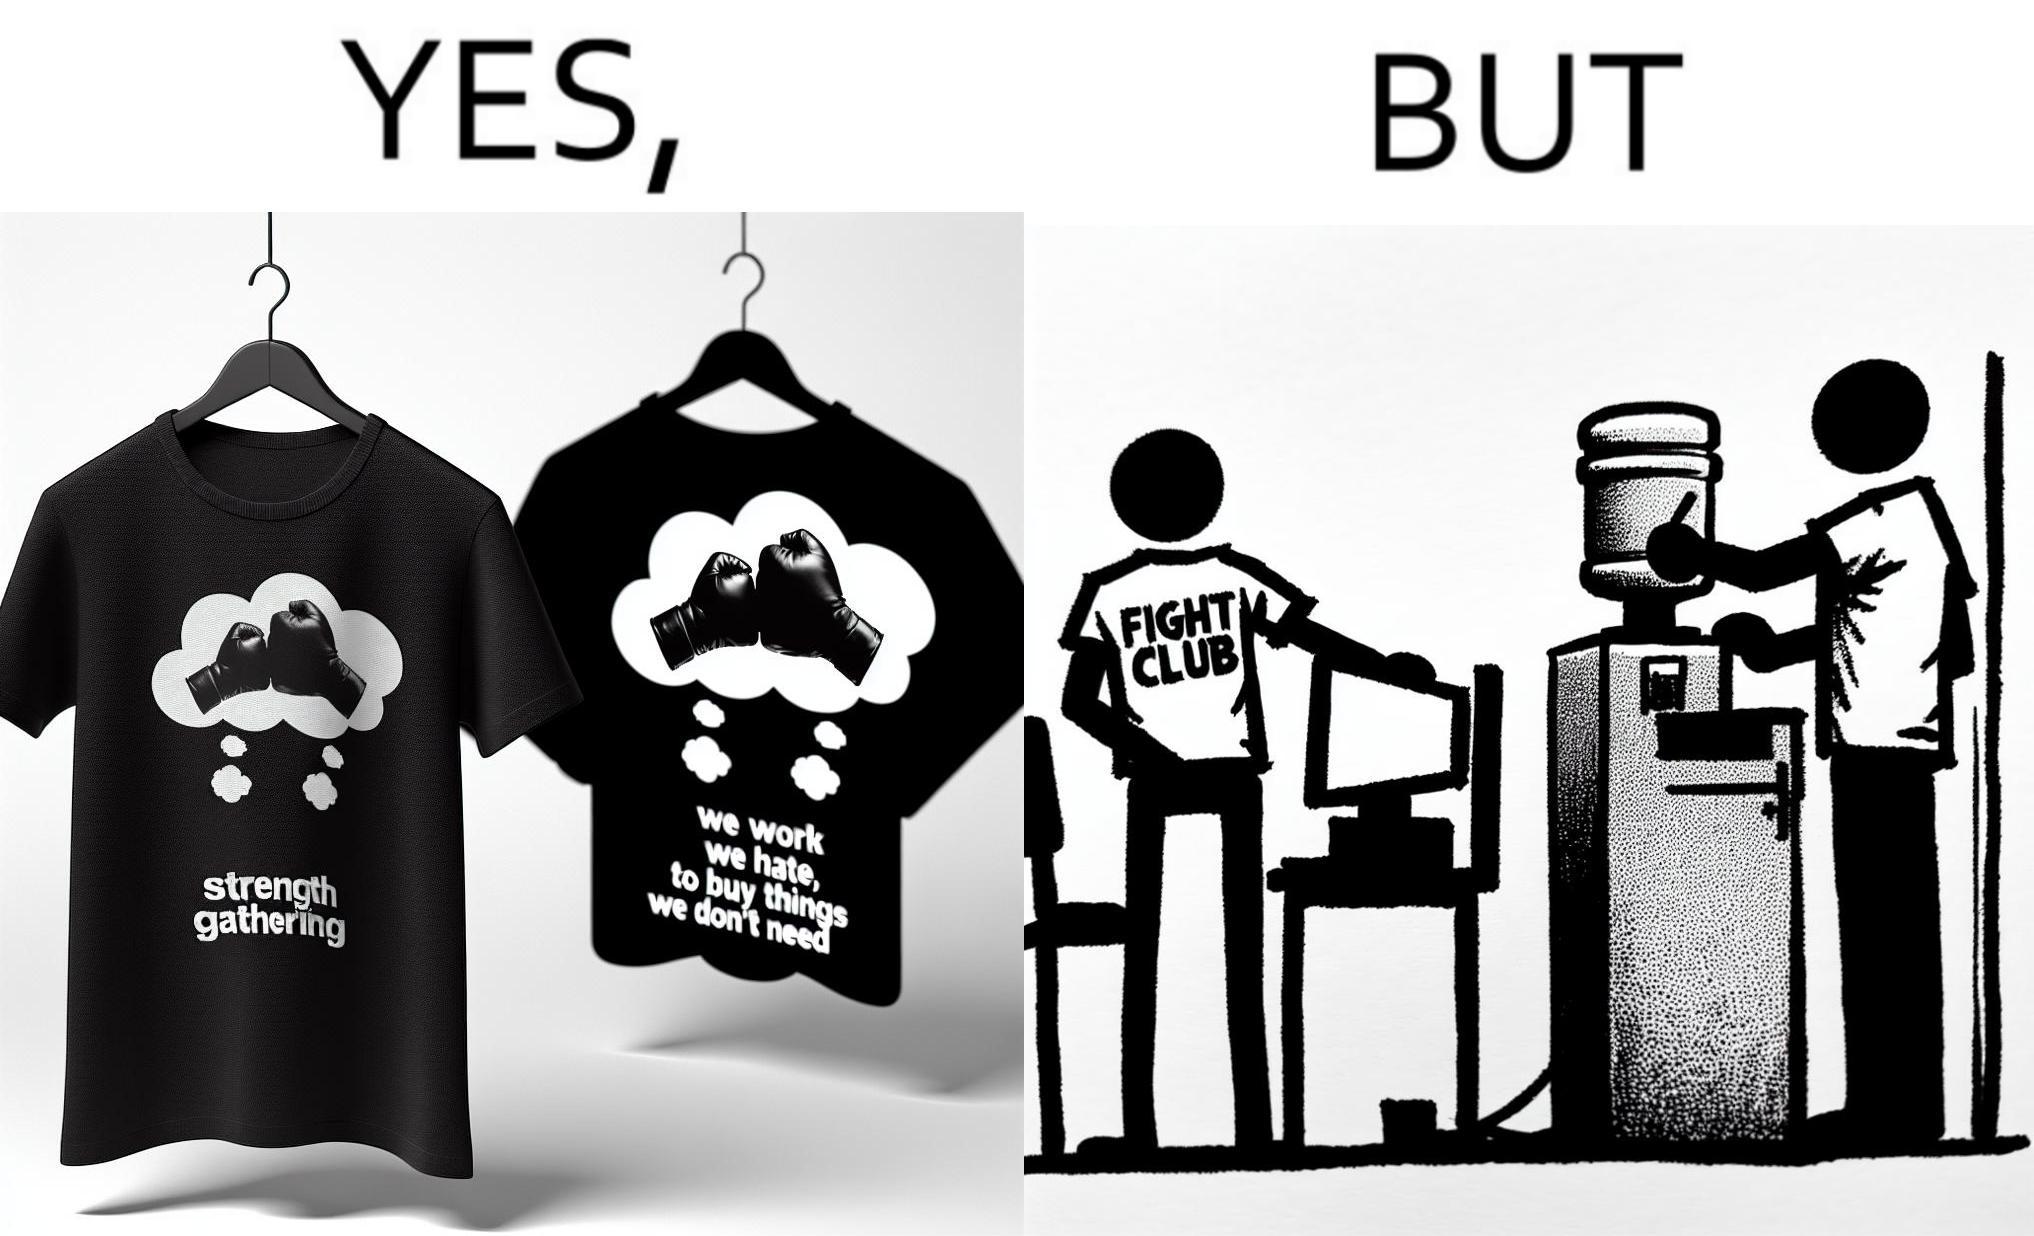What is the satirical meaning behind this image? The image is ironical, as the t-shirt says "We work jobs we hate, to buy sh*t we don't need", which is a rebellious message against the construct of office jobs. However, the person wearing the t-shirt seems to be working in an office environment. Also, the t-shirt might have been bought using the money earned via the very same job. 